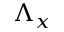Convert formula to latex. <formula><loc_0><loc_0><loc_500><loc_500>\Lambda _ { x }</formula> 